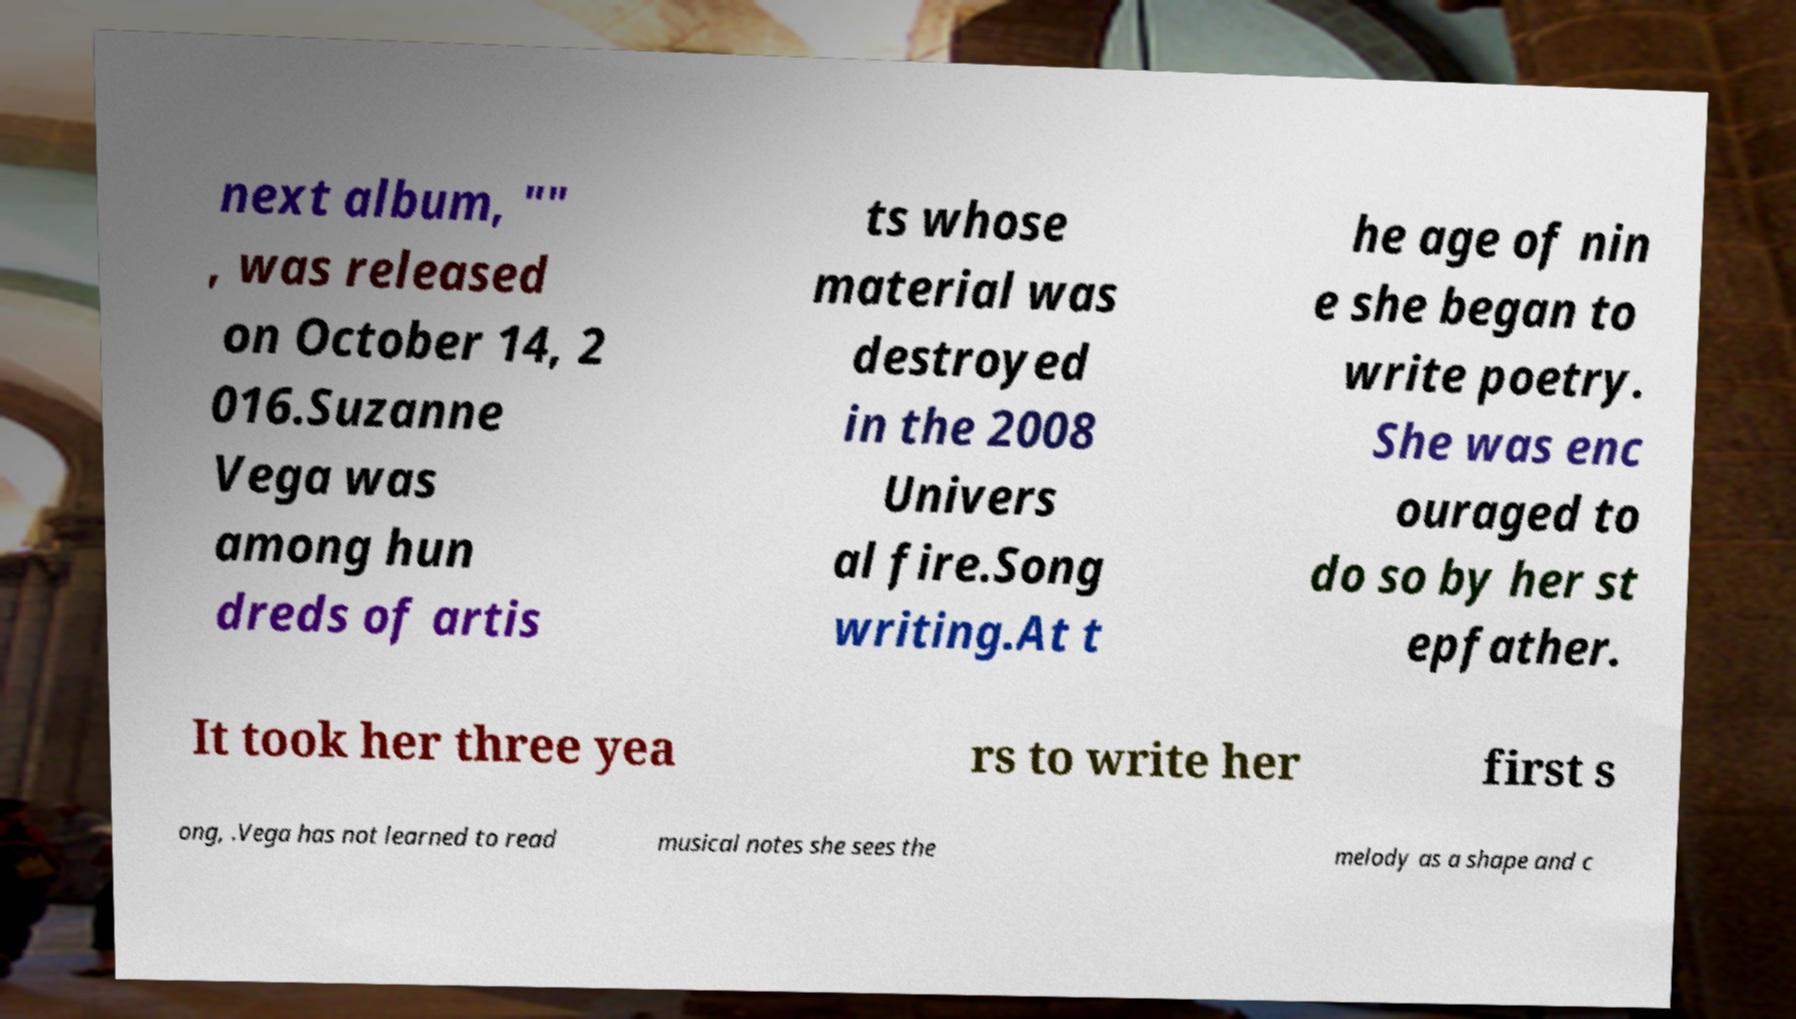Please identify and transcribe the text found in this image. next album, "" , was released on October 14, 2 016.Suzanne Vega was among hun dreds of artis ts whose material was destroyed in the 2008 Univers al fire.Song writing.At t he age of nin e she began to write poetry. She was enc ouraged to do so by her st epfather. It took her three yea rs to write her first s ong, .Vega has not learned to read musical notes she sees the melody as a shape and c 